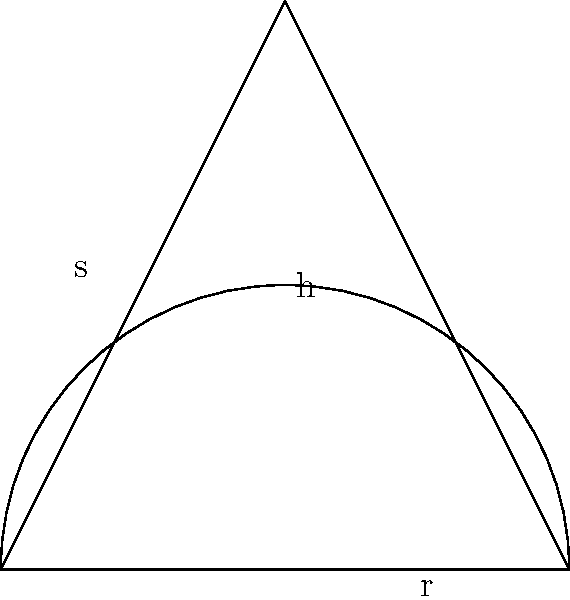You're designing a special conical cupcake wrapper for your homemade treats. The wrapper has a radius of 5 cm at the base and a height of 8 cm. What is the surface area of the wrapper, excluding the circular base? Round your answer to the nearest square centimeter. To find the surface area of the conical wrapper, we need to calculate the lateral surface area of a cone. Let's approach this step-by-step:

1) First, we need to find the slant height (s) of the cone. We can do this using the Pythagorean theorem:

   $s^2 = r^2 + h^2$

   Where $r$ is the radius and $h$ is the height.

2) Plugging in our values:

   $s^2 = 5^2 + 8^2 = 25 + 64 = 89$

3) Taking the square root:

   $s = \sqrt{89} \approx 9.43$ cm

4) Now that we have the slant height, we can calculate the lateral surface area using the formula:

   $A = \pi rs$

   Where $A$ is the area, $r$ is the radius, and $s$ is the slant height.

5) Plugging in our values:

   $A = \pi \cdot 5 \cdot 9.43 \approx 148.11$ cm²

6) Rounding to the nearest square centimeter:

   $A \approx 148$ cm²
Answer: 148 cm² 